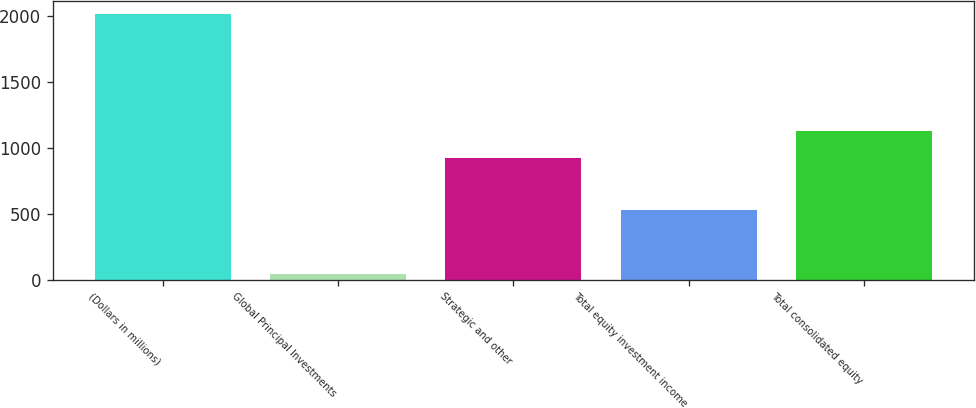Convert chart to OTSL. <chart><loc_0><loc_0><loc_500><loc_500><bar_chart><fcel>(Dollars in millions)<fcel>Global Principal Investments<fcel>Strategic and other<fcel>Total equity investment income<fcel>Total consolidated equity<nl><fcel>2014<fcel>46<fcel>922.6<fcel>529<fcel>1130<nl></chart> 